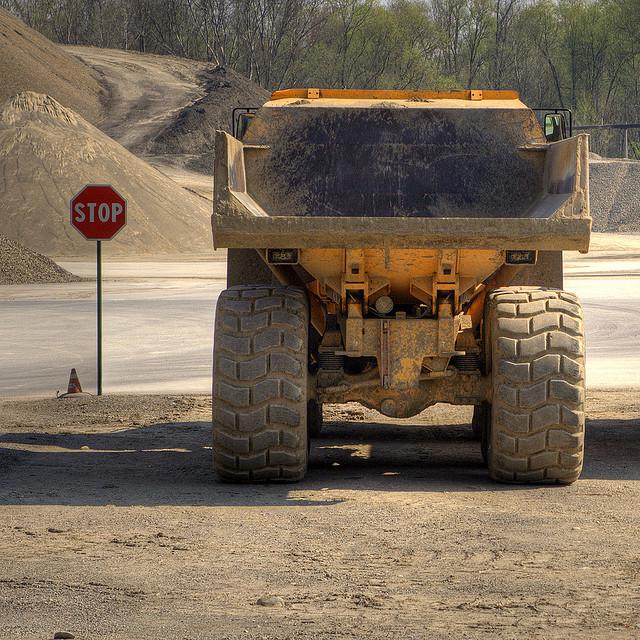What job does the truck do?
Write a very short answer. Move dirt and rocks. What kind of truck is this?
Short answer required. Dump. What does the sign say?
Write a very short answer. Stop. 